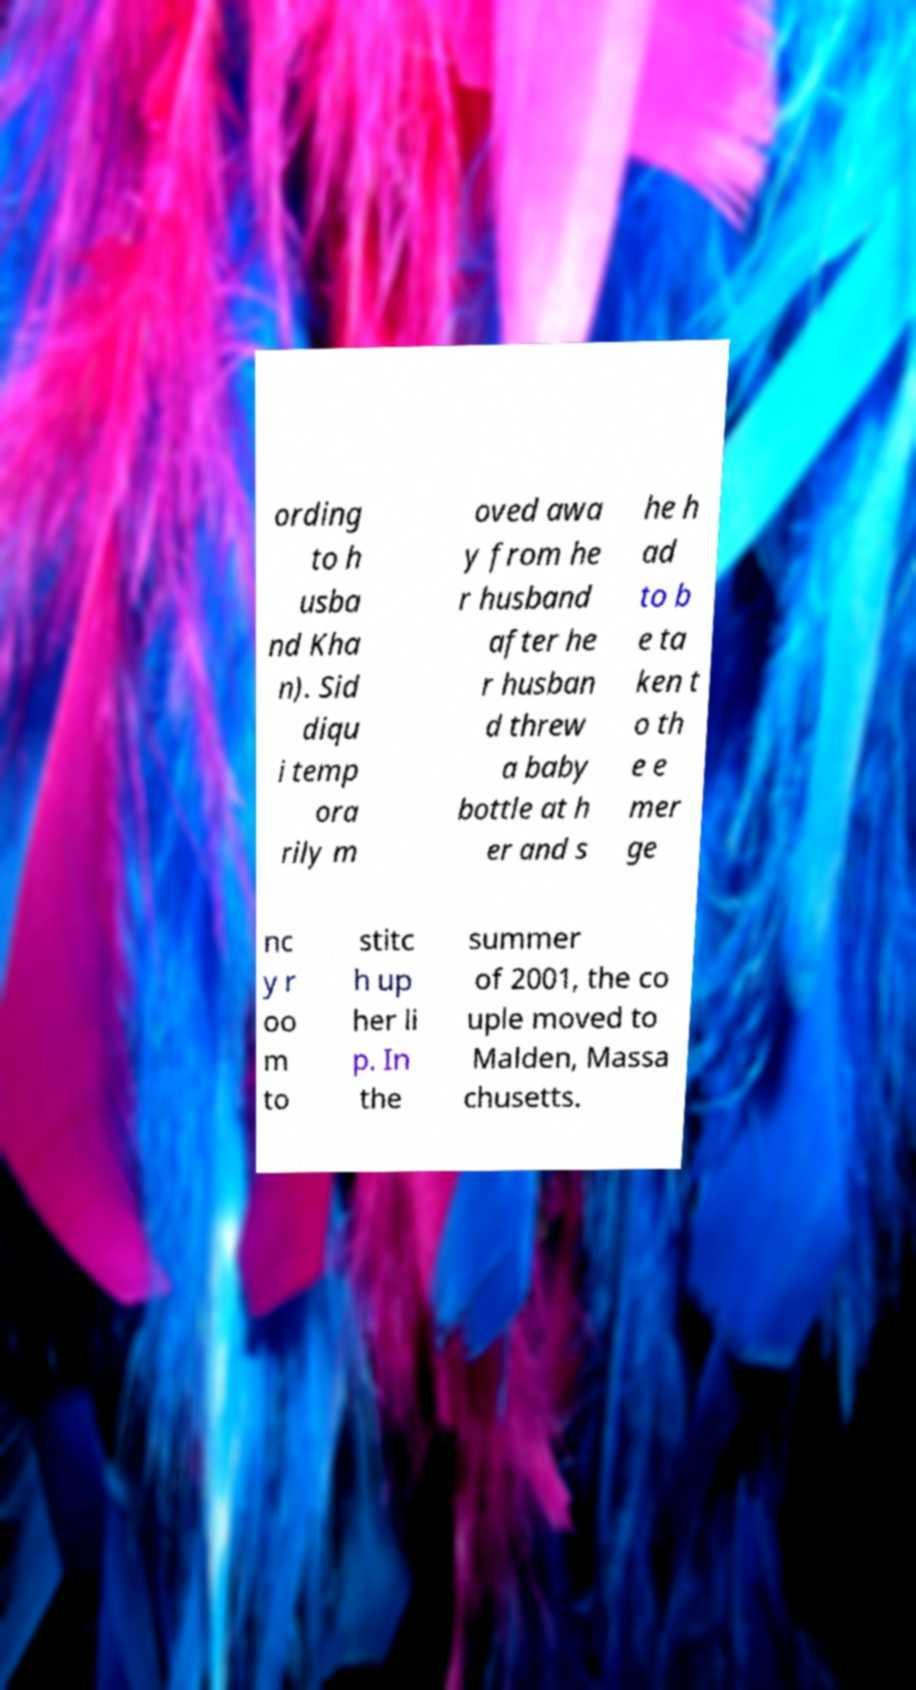For documentation purposes, I need the text within this image transcribed. Could you provide that? ording to h usba nd Kha n). Sid diqu i temp ora rily m oved awa y from he r husband after he r husban d threw a baby bottle at h er and s he h ad to b e ta ken t o th e e mer ge nc y r oo m to stitc h up her li p. In the summer of 2001, the co uple moved to Malden, Massa chusetts. 